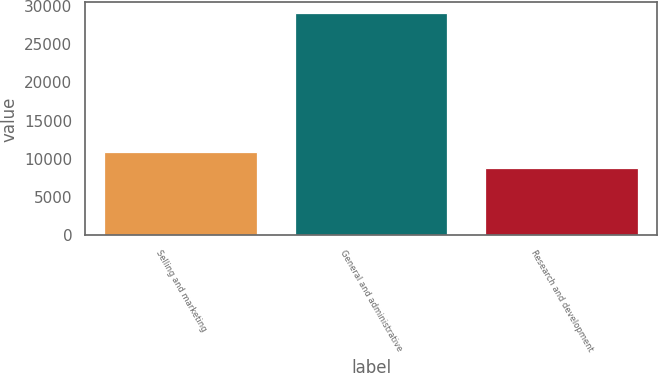Convert chart. <chart><loc_0><loc_0><loc_500><loc_500><bar_chart><fcel>Selling and marketing<fcel>General and administrative<fcel>Research and development<nl><fcel>10879.4<fcel>28991<fcel>8867<nl></chart> 